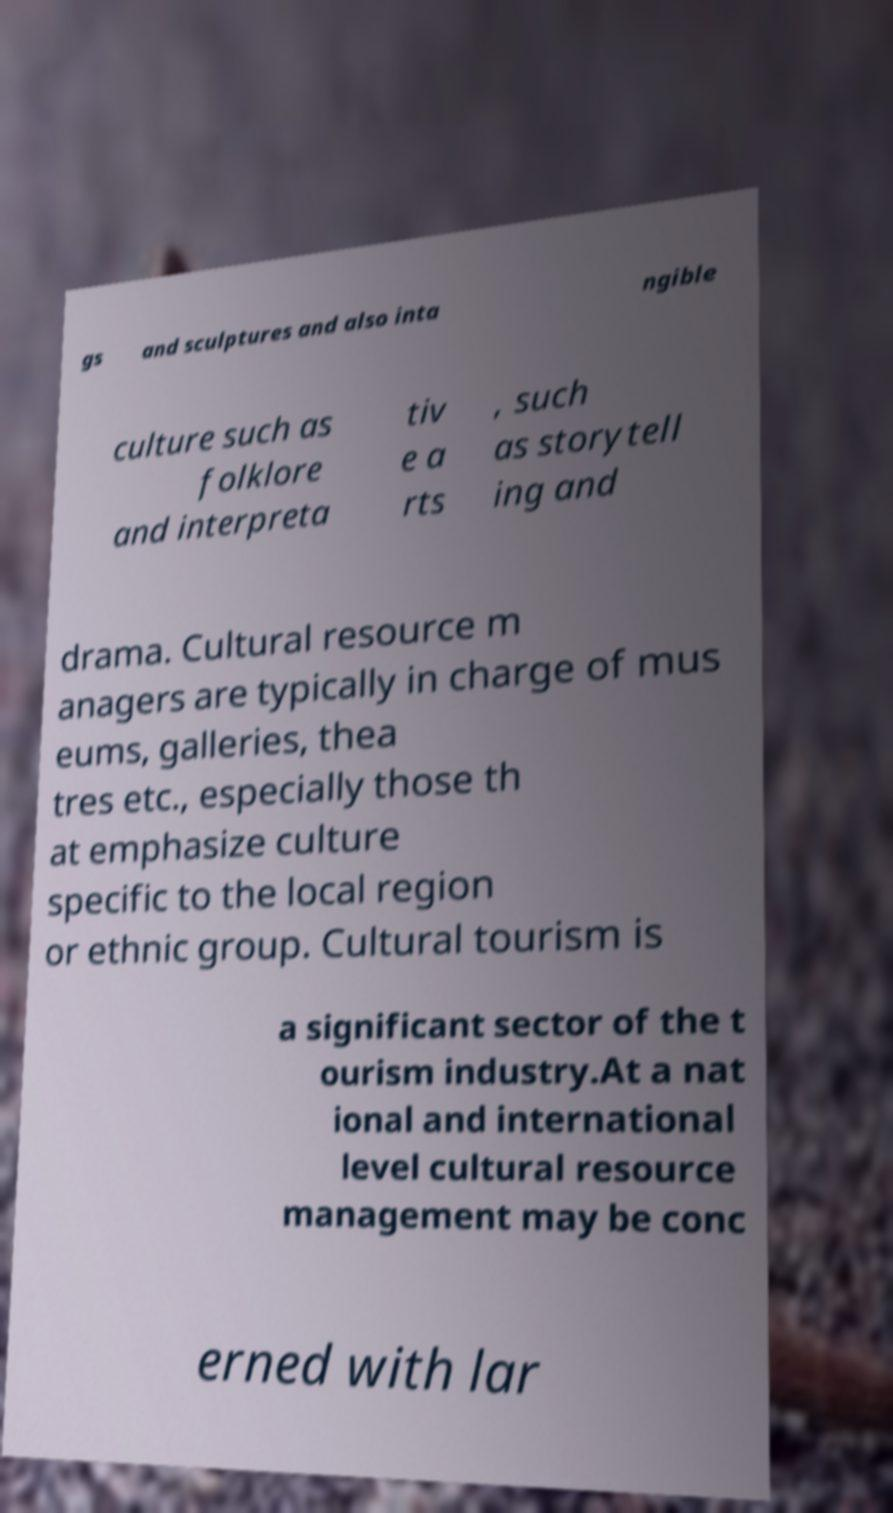Can you read and provide the text displayed in the image?This photo seems to have some interesting text. Can you extract and type it out for me? gs and sculptures and also inta ngible culture such as folklore and interpreta tiv e a rts , such as storytell ing and drama. Cultural resource m anagers are typically in charge of mus eums, galleries, thea tres etc., especially those th at emphasize culture specific to the local region or ethnic group. Cultural tourism is a significant sector of the t ourism industry.At a nat ional and international level cultural resource management may be conc erned with lar 